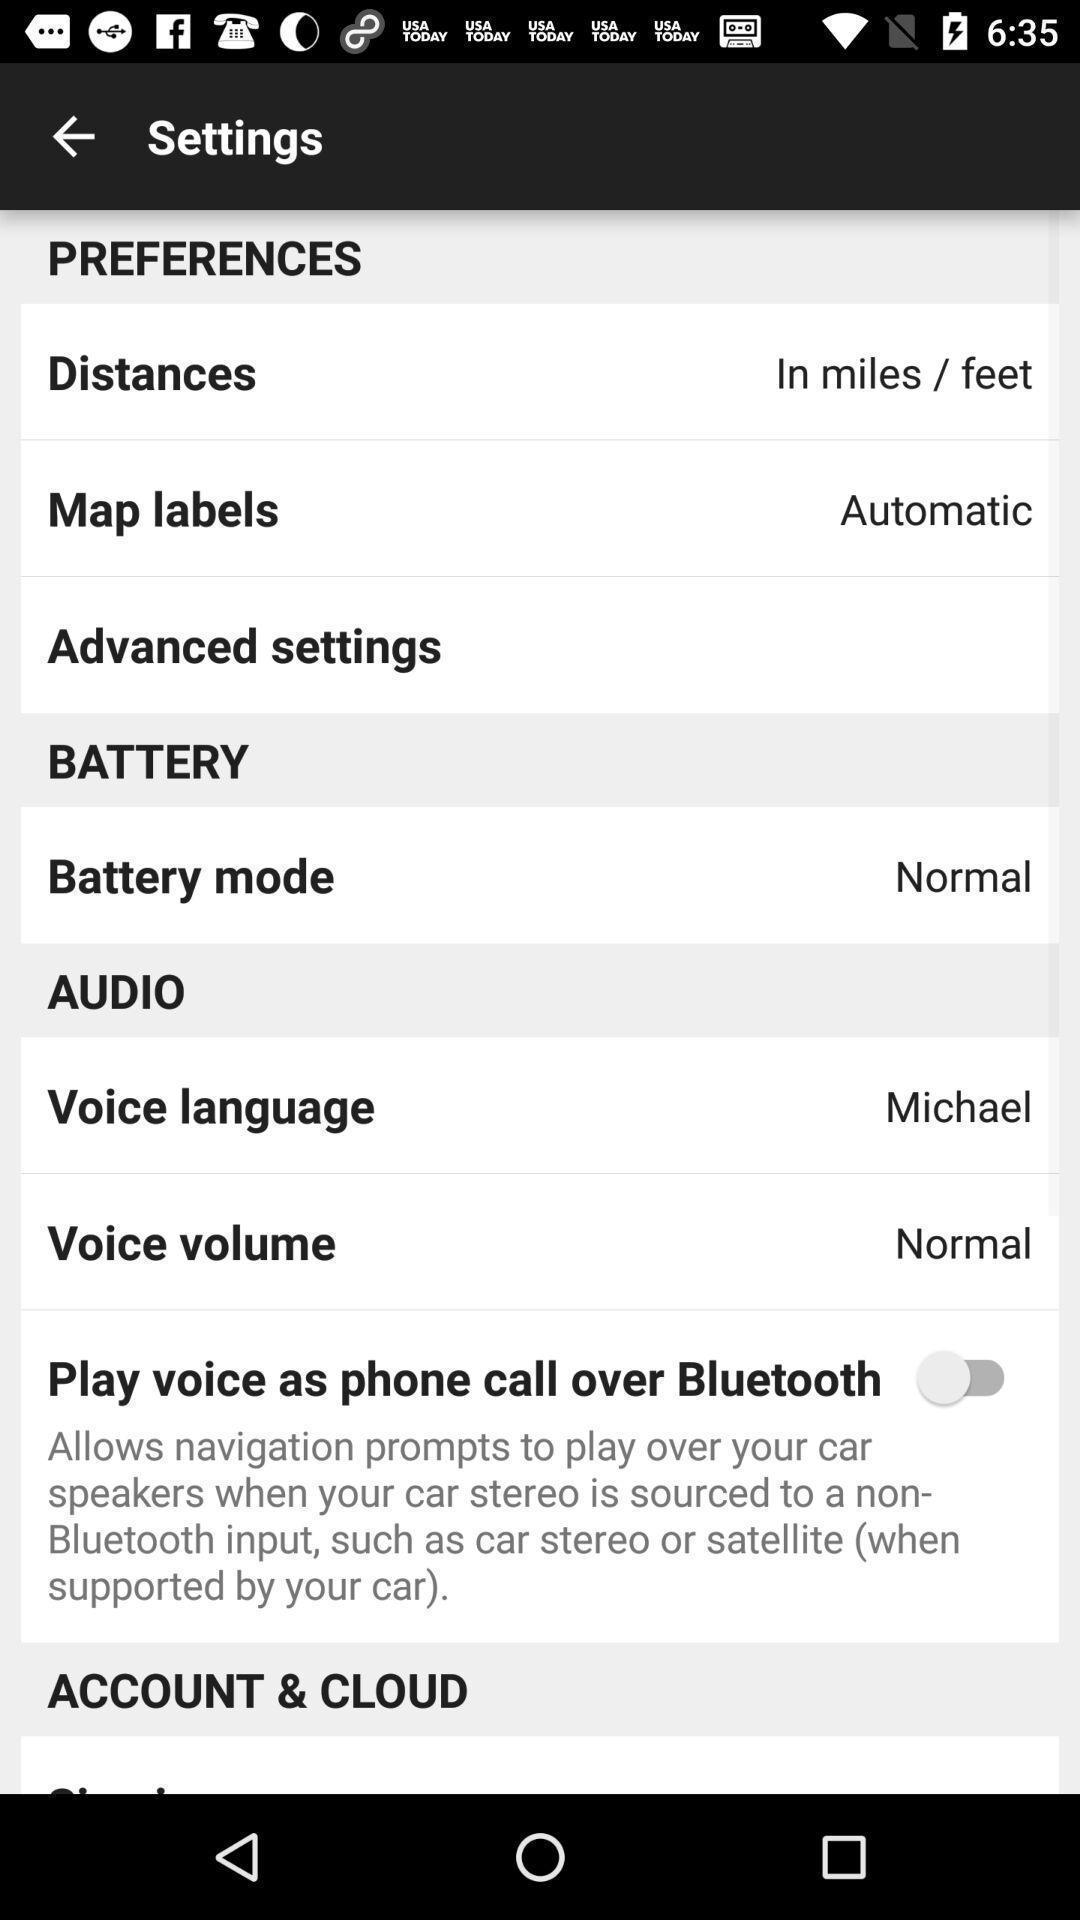Explain what's happening in this screen capture. Screen showing settings page. 